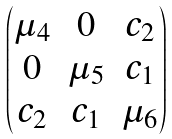<formula> <loc_0><loc_0><loc_500><loc_500>\begin{pmatrix} \mu _ { 4 } & 0 & c _ { 2 } \\ 0 & \mu _ { 5 } & c _ { 1 } \\ c _ { 2 } & c _ { 1 } & \mu _ { 6 } \end{pmatrix}</formula> 